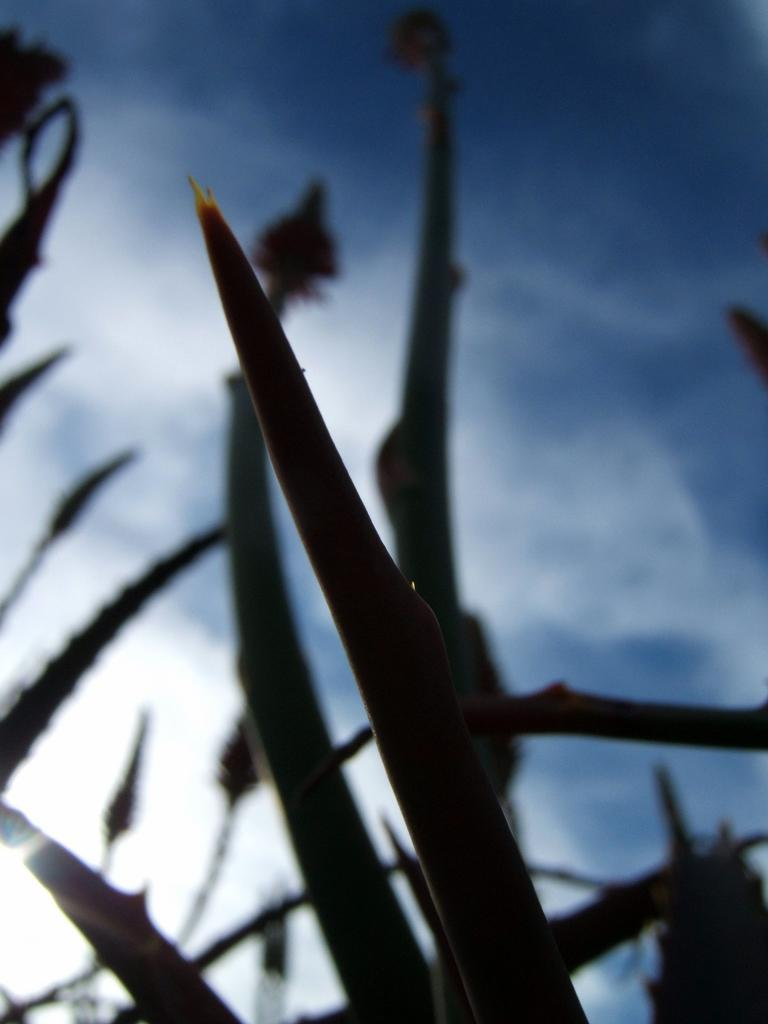What type of living organisms can be seen in the image? Plants can be seen in the image. What is visible in the background of the image? The sky is visible in the background of the image. What is the color of the sky in the image? The color of the sky is blue. Can you see any guitar strings in the image? There is no guitar or guitar strings present in the image. Is there a cobweb visible on the plants in the image? There is no cobweb visible on the plants in the image. 